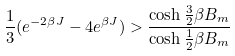<formula> <loc_0><loc_0><loc_500><loc_500>\frac { 1 } { 3 } ( e ^ { - 2 \beta J } - 4 e ^ { \beta J } ) > \frac { \cosh \frac { 3 } { 2 } \beta B _ { m } } { \cosh \frac { 1 } { 2 } \beta B _ { m } }</formula> 